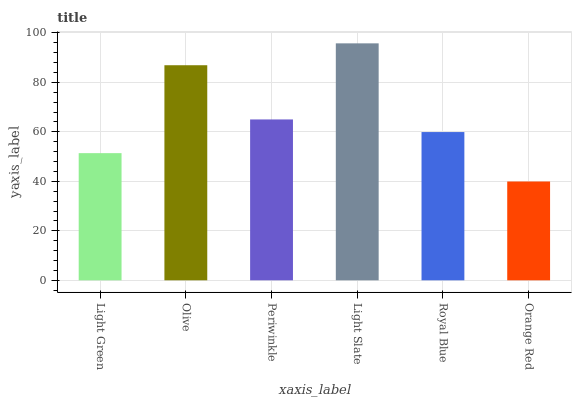Is Orange Red the minimum?
Answer yes or no. Yes. Is Light Slate the maximum?
Answer yes or no. Yes. Is Olive the minimum?
Answer yes or no. No. Is Olive the maximum?
Answer yes or no. No. Is Olive greater than Light Green?
Answer yes or no. Yes. Is Light Green less than Olive?
Answer yes or no. Yes. Is Light Green greater than Olive?
Answer yes or no. No. Is Olive less than Light Green?
Answer yes or no. No. Is Periwinkle the high median?
Answer yes or no. Yes. Is Royal Blue the low median?
Answer yes or no. Yes. Is Light Green the high median?
Answer yes or no. No. Is Olive the low median?
Answer yes or no. No. 